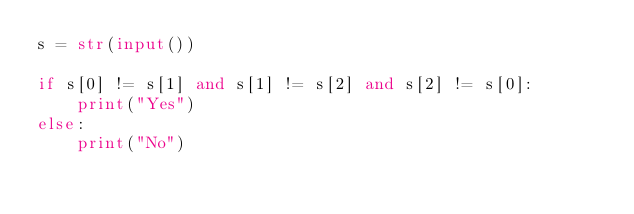<code> <loc_0><loc_0><loc_500><loc_500><_Python_>s = str(input())

if s[0] != s[1] and s[1] != s[2] and s[2] != s[0]:
    print("Yes")
else:
    print("No")
</code> 